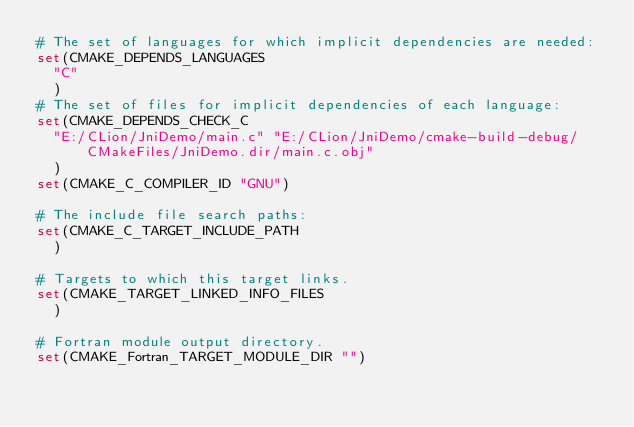Convert code to text. <code><loc_0><loc_0><loc_500><loc_500><_CMake_># The set of languages for which implicit dependencies are needed:
set(CMAKE_DEPENDS_LANGUAGES
  "C"
  )
# The set of files for implicit dependencies of each language:
set(CMAKE_DEPENDS_CHECK_C
  "E:/CLion/JniDemo/main.c" "E:/CLion/JniDemo/cmake-build-debug/CMakeFiles/JniDemo.dir/main.c.obj"
  )
set(CMAKE_C_COMPILER_ID "GNU")

# The include file search paths:
set(CMAKE_C_TARGET_INCLUDE_PATH
  )

# Targets to which this target links.
set(CMAKE_TARGET_LINKED_INFO_FILES
  )

# Fortran module output directory.
set(CMAKE_Fortran_TARGET_MODULE_DIR "")
</code> 